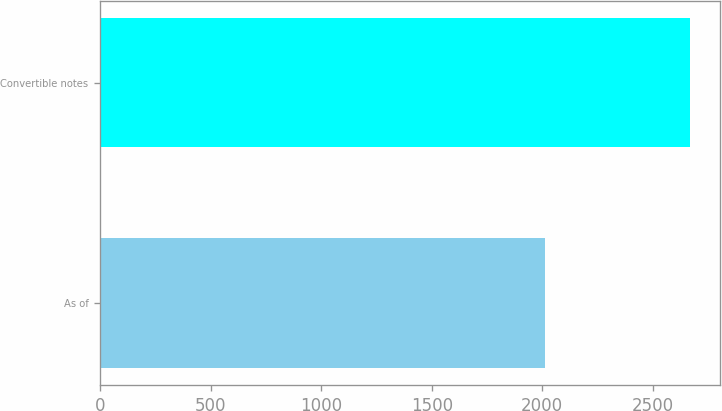Convert chart to OTSL. <chart><loc_0><loc_0><loc_500><loc_500><bar_chart><fcel>As of<fcel>Convertible notes<nl><fcel>2012<fcel>2669<nl></chart> 